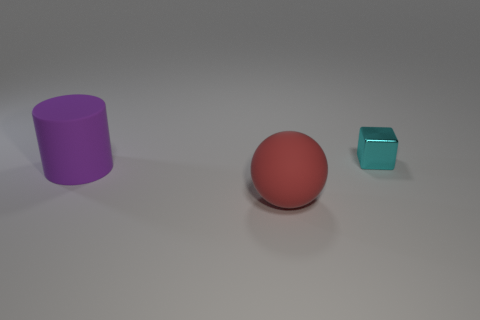The object that is both behind the large red rubber thing and to the right of the purple rubber cylinder is made of what material?
Make the answer very short. Metal. There is a tiny metallic object that is behind the rubber sphere; is there a big purple matte cylinder left of it?
Your response must be concise. Yes. How many other big cylinders are the same color as the large rubber cylinder?
Offer a terse response. 0. Are the purple cylinder and the large red sphere made of the same material?
Provide a short and direct response. Yes. Are there any large purple objects to the left of the large red matte object?
Your answer should be very brief. Yes. There is a cyan cube that is right of the big matte object behind the rubber ball; what is it made of?
Provide a short and direct response. Metal. What color is the object that is behind the big red ball and left of the tiny shiny block?
Offer a very short reply. Purple. There is a thing in front of the purple matte object; is its size the same as the big cylinder?
Give a very brief answer. Yes. Is there any other thing that is the same shape as the small thing?
Your response must be concise. No. Does the large red sphere have the same material as the thing that is behind the large purple rubber thing?
Provide a short and direct response. No. 